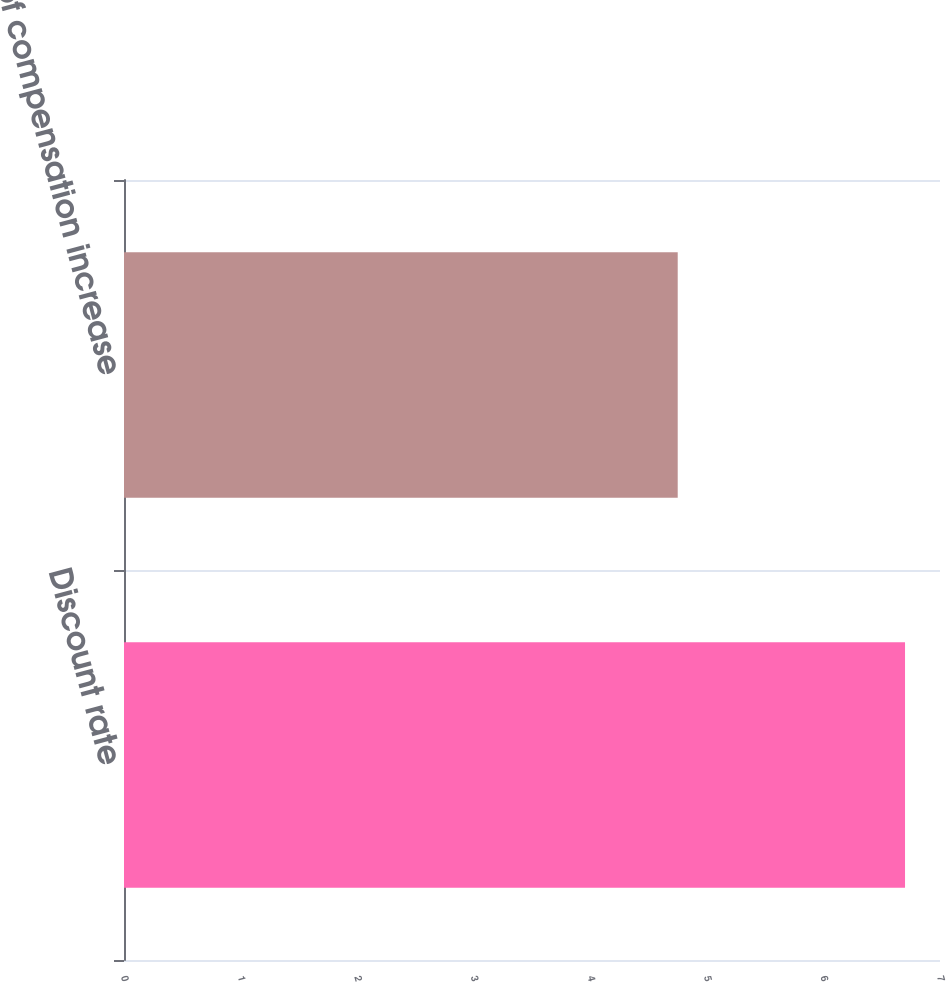Convert chart to OTSL. <chart><loc_0><loc_0><loc_500><loc_500><bar_chart><fcel>Discount rate<fcel>Rate of compensation increase<nl><fcel>6.7<fcel>4.75<nl></chart> 